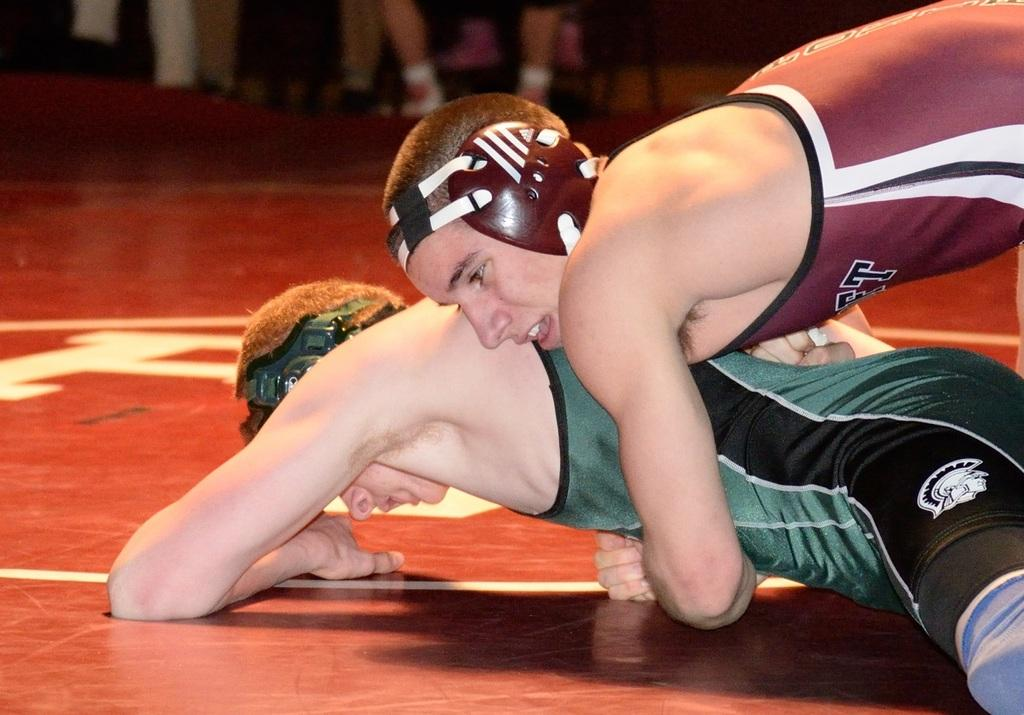How many people are in the image? There are persons in the image. What are the persons wearing? The persons are wearing clothes. What activity are the persons engaged in? The persons are engaged in wrestling. What invention can be seen in the hands of the persons in the image? There is no invention visible in the hands of the persons in the image; they are engaged in wrestling. 